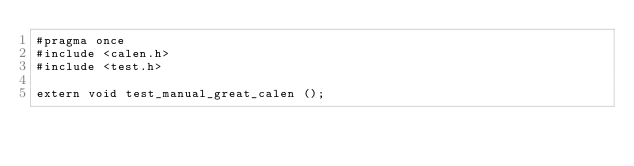Convert code to text. <code><loc_0><loc_0><loc_500><loc_500><_C_>#pragma once
#include <calen.h>
#include <test.h>

extern void test_manual_great_calen ();
</code> 